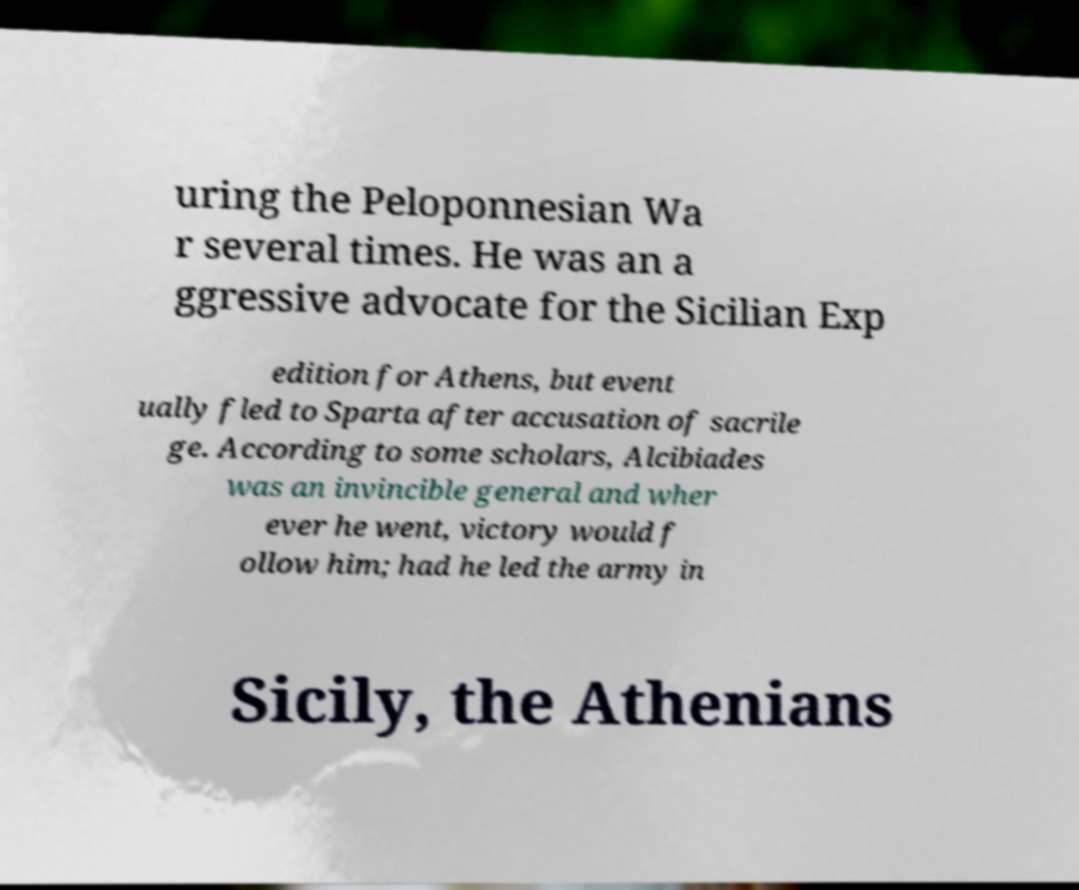Can you accurately transcribe the text from the provided image for me? uring the Peloponnesian Wa r several times. He was an a ggressive advocate for the Sicilian Exp edition for Athens, but event ually fled to Sparta after accusation of sacrile ge. According to some scholars, Alcibiades was an invincible general and wher ever he went, victory would f ollow him; had he led the army in Sicily, the Athenians 